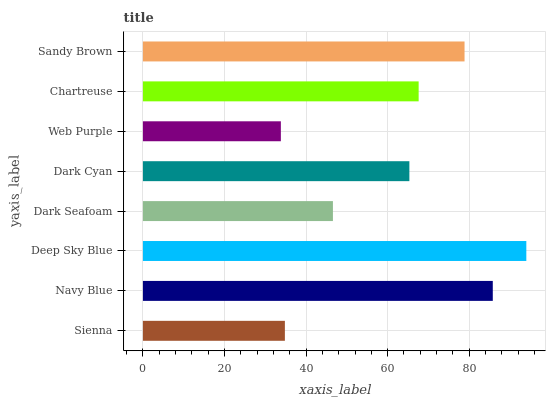Is Web Purple the minimum?
Answer yes or no. Yes. Is Deep Sky Blue the maximum?
Answer yes or no. Yes. Is Navy Blue the minimum?
Answer yes or no. No. Is Navy Blue the maximum?
Answer yes or no. No. Is Navy Blue greater than Sienna?
Answer yes or no. Yes. Is Sienna less than Navy Blue?
Answer yes or no. Yes. Is Sienna greater than Navy Blue?
Answer yes or no. No. Is Navy Blue less than Sienna?
Answer yes or no. No. Is Chartreuse the high median?
Answer yes or no. Yes. Is Dark Cyan the low median?
Answer yes or no. Yes. Is Dark Cyan the high median?
Answer yes or no. No. Is Web Purple the low median?
Answer yes or no. No. 